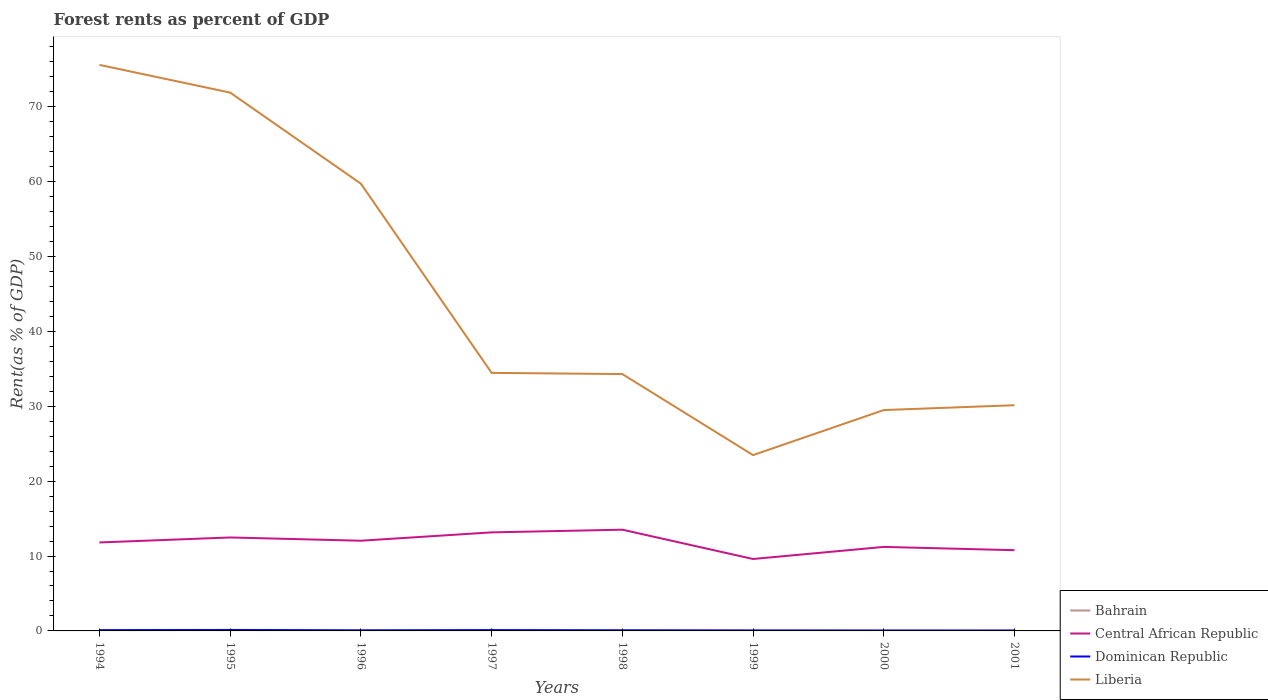Across all years, what is the maximum forest rent in Bahrain?
Provide a succinct answer. 0. In which year was the forest rent in Central African Republic maximum?
Offer a terse response. 1999. What is the total forest rent in Liberia in the graph?
Your response must be concise. 10.82. What is the difference between the highest and the second highest forest rent in Central African Republic?
Give a very brief answer. 3.91. What is the difference between the highest and the lowest forest rent in Bahrain?
Offer a terse response. 4. How many lines are there?
Provide a succinct answer. 4. How many years are there in the graph?
Provide a succinct answer. 8. Does the graph contain any zero values?
Provide a short and direct response. No. Does the graph contain grids?
Your response must be concise. No. How many legend labels are there?
Your answer should be very brief. 4. What is the title of the graph?
Your response must be concise. Forest rents as percent of GDP. What is the label or title of the X-axis?
Keep it short and to the point. Years. What is the label or title of the Y-axis?
Make the answer very short. Rent(as % of GDP). What is the Rent(as % of GDP) of Bahrain in 1994?
Make the answer very short. 0. What is the Rent(as % of GDP) of Central African Republic in 1994?
Your answer should be very brief. 11.81. What is the Rent(as % of GDP) in Dominican Republic in 1994?
Make the answer very short. 0.11. What is the Rent(as % of GDP) of Liberia in 1994?
Make the answer very short. 75.57. What is the Rent(as % of GDP) in Bahrain in 1995?
Ensure brevity in your answer.  0. What is the Rent(as % of GDP) in Central African Republic in 1995?
Your answer should be very brief. 12.48. What is the Rent(as % of GDP) in Dominican Republic in 1995?
Your response must be concise. 0.13. What is the Rent(as % of GDP) of Liberia in 1995?
Keep it short and to the point. 71.87. What is the Rent(as % of GDP) of Bahrain in 1996?
Offer a very short reply. 0. What is the Rent(as % of GDP) of Central African Republic in 1996?
Make the answer very short. 12.04. What is the Rent(as % of GDP) in Dominican Republic in 1996?
Your answer should be compact. 0.08. What is the Rent(as % of GDP) of Liberia in 1996?
Make the answer very short. 59.71. What is the Rent(as % of GDP) in Bahrain in 1997?
Your answer should be compact. 0. What is the Rent(as % of GDP) in Central African Republic in 1997?
Provide a short and direct response. 13.16. What is the Rent(as % of GDP) in Dominican Republic in 1997?
Make the answer very short. 0.11. What is the Rent(as % of GDP) in Liberia in 1997?
Make the answer very short. 34.45. What is the Rent(as % of GDP) in Bahrain in 1998?
Your answer should be very brief. 0. What is the Rent(as % of GDP) in Central African Republic in 1998?
Keep it short and to the point. 13.52. What is the Rent(as % of GDP) of Dominican Republic in 1998?
Your answer should be very brief. 0.09. What is the Rent(as % of GDP) in Liberia in 1998?
Your response must be concise. 34.29. What is the Rent(as % of GDP) of Bahrain in 1999?
Provide a short and direct response. 0. What is the Rent(as % of GDP) in Central African Republic in 1999?
Offer a very short reply. 9.6. What is the Rent(as % of GDP) in Dominican Republic in 1999?
Make the answer very short. 0.07. What is the Rent(as % of GDP) in Liberia in 1999?
Provide a succinct answer. 23.47. What is the Rent(as % of GDP) of Bahrain in 2000?
Provide a short and direct response. 0. What is the Rent(as % of GDP) of Central African Republic in 2000?
Offer a very short reply. 11.22. What is the Rent(as % of GDP) of Dominican Republic in 2000?
Make the answer very short. 0.06. What is the Rent(as % of GDP) in Liberia in 2000?
Provide a succinct answer. 29.49. What is the Rent(as % of GDP) in Bahrain in 2001?
Your response must be concise. 0. What is the Rent(as % of GDP) of Central African Republic in 2001?
Provide a succinct answer. 10.78. What is the Rent(as % of GDP) of Dominican Republic in 2001?
Make the answer very short. 0.06. What is the Rent(as % of GDP) in Liberia in 2001?
Offer a very short reply. 30.13. Across all years, what is the maximum Rent(as % of GDP) of Bahrain?
Offer a terse response. 0. Across all years, what is the maximum Rent(as % of GDP) of Central African Republic?
Provide a short and direct response. 13.52. Across all years, what is the maximum Rent(as % of GDP) of Dominican Republic?
Your answer should be very brief. 0.13. Across all years, what is the maximum Rent(as % of GDP) of Liberia?
Offer a terse response. 75.57. Across all years, what is the minimum Rent(as % of GDP) in Bahrain?
Keep it short and to the point. 0. Across all years, what is the minimum Rent(as % of GDP) of Central African Republic?
Your response must be concise. 9.6. Across all years, what is the minimum Rent(as % of GDP) of Dominican Republic?
Your answer should be compact. 0.06. Across all years, what is the minimum Rent(as % of GDP) of Liberia?
Your answer should be very brief. 23.47. What is the total Rent(as % of GDP) in Bahrain in the graph?
Your answer should be very brief. 0.01. What is the total Rent(as % of GDP) in Central African Republic in the graph?
Your response must be concise. 94.6. What is the total Rent(as % of GDP) of Dominican Republic in the graph?
Offer a terse response. 0.7. What is the total Rent(as % of GDP) in Liberia in the graph?
Give a very brief answer. 358.99. What is the difference between the Rent(as % of GDP) of Bahrain in 1994 and that in 1995?
Ensure brevity in your answer.  -0. What is the difference between the Rent(as % of GDP) in Central African Republic in 1994 and that in 1995?
Your answer should be very brief. -0.67. What is the difference between the Rent(as % of GDP) in Dominican Republic in 1994 and that in 1995?
Your answer should be compact. -0.02. What is the difference between the Rent(as % of GDP) in Liberia in 1994 and that in 1995?
Keep it short and to the point. 3.7. What is the difference between the Rent(as % of GDP) in Bahrain in 1994 and that in 1996?
Make the answer very short. -0. What is the difference between the Rent(as % of GDP) in Central African Republic in 1994 and that in 1996?
Provide a short and direct response. -0.23. What is the difference between the Rent(as % of GDP) of Dominican Republic in 1994 and that in 1996?
Ensure brevity in your answer.  0.02. What is the difference between the Rent(as % of GDP) of Liberia in 1994 and that in 1996?
Offer a very short reply. 15.86. What is the difference between the Rent(as % of GDP) in Bahrain in 1994 and that in 1997?
Offer a very short reply. -0. What is the difference between the Rent(as % of GDP) in Central African Republic in 1994 and that in 1997?
Your response must be concise. -1.35. What is the difference between the Rent(as % of GDP) of Dominican Republic in 1994 and that in 1997?
Make the answer very short. -0.01. What is the difference between the Rent(as % of GDP) in Liberia in 1994 and that in 1997?
Your answer should be very brief. 41.12. What is the difference between the Rent(as % of GDP) in Bahrain in 1994 and that in 1998?
Your answer should be compact. -0. What is the difference between the Rent(as % of GDP) in Central African Republic in 1994 and that in 1998?
Keep it short and to the point. -1.7. What is the difference between the Rent(as % of GDP) of Dominican Republic in 1994 and that in 1998?
Ensure brevity in your answer.  0.02. What is the difference between the Rent(as % of GDP) of Liberia in 1994 and that in 1998?
Ensure brevity in your answer.  41.28. What is the difference between the Rent(as % of GDP) of Bahrain in 1994 and that in 1999?
Your answer should be very brief. -0. What is the difference between the Rent(as % of GDP) in Central African Republic in 1994 and that in 1999?
Give a very brief answer. 2.21. What is the difference between the Rent(as % of GDP) in Dominican Republic in 1994 and that in 1999?
Keep it short and to the point. 0.04. What is the difference between the Rent(as % of GDP) of Liberia in 1994 and that in 1999?
Offer a terse response. 52.1. What is the difference between the Rent(as % of GDP) in Central African Republic in 1994 and that in 2000?
Provide a short and direct response. 0.59. What is the difference between the Rent(as % of GDP) of Dominican Republic in 1994 and that in 2000?
Your response must be concise. 0.04. What is the difference between the Rent(as % of GDP) of Liberia in 1994 and that in 2000?
Give a very brief answer. 46.09. What is the difference between the Rent(as % of GDP) in Central African Republic in 1994 and that in 2001?
Make the answer very short. 1.03. What is the difference between the Rent(as % of GDP) in Dominican Republic in 1994 and that in 2001?
Your answer should be very brief. 0.05. What is the difference between the Rent(as % of GDP) in Liberia in 1994 and that in 2001?
Your answer should be compact. 45.44. What is the difference between the Rent(as % of GDP) in Bahrain in 1995 and that in 1996?
Your response must be concise. -0. What is the difference between the Rent(as % of GDP) of Central African Republic in 1995 and that in 1996?
Your answer should be compact. 0.44. What is the difference between the Rent(as % of GDP) in Dominican Republic in 1995 and that in 1996?
Provide a short and direct response. 0.05. What is the difference between the Rent(as % of GDP) of Liberia in 1995 and that in 1996?
Offer a terse response. 12.16. What is the difference between the Rent(as % of GDP) of Bahrain in 1995 and that in 1997?
Offer a very short reply. -0. What is the difference between the Rent(as % of GDP) in Central African Republic in 1995 and that in 1997?
Give a very brief answer. -0.68. What is the difference between the Rent(as % of GDP) in Dominican Republic in 1995 and that in 1997?
Keep it short and to the point. 0.02. What is the difference between the Rent(as % of GDP) of Liberia in 1995 and that in 1997?
Your answer should be very brief. 37.42. What is the difference between the Rent(as % of GDP) of Bahrain in 1995 and that in 1998?
Keep it short and to the point. -0. What is the difference between the Rent(as % of GDP) in Central African Republic in 1995 and that in 1998?
Your answer should be very brief. -1.04. What is the difference between the Rent(as % of GDP) of Dominican Republic in 1995 and that in 1998?
Provide a succinct answer. 0.04. What is the difference between the Rent(as % of GDP) in Liberia in 1995 and that in 1998?
Make the answer very short. 37.58. What is the difference between the Rent(as % of GDP) in Bahrain in 1995 and that in 1999?
Provide a succinct answer. 0. What is the difference between the Rent(as % of GDP) in Central African Republic in 1995 and that in 1999?
Provide a succinct answer. 2.88. What is the difference between the Rent(as % of GDP) of Dominican Republic in 1995 and that in 1999?
Your answer should be very brief. 0.06. What is the difference between the Rent(as % of GDP) of Liberia in 1995 and that in 1999?
Offer a terse response. 48.4. What is the difference between the Rent(as % of GDP) of Bahrain in 1995 and that in 2000?
Provide a short and direct response. 0. What is the difference between the Rent(as % of GDP) of Central African Republic in 1995 and that in 2000?
Provide a short and direct response. 1.26. What is the difference between the Rent(as % of GDP) in Dominican Republic in 1995 and that in 2000?
Your answer should be compact. 0.07. What is the difference between the Rent(as % of GDP) of Liberia in 1995 and that in 2000?
Offer a terse response. 42.38. What is the difference between the Rent(as % of GDP) of Central African Republic in 1995 and that in 2001?
Ensure brevity in your answer.  1.7. What is the difference between the Rent(as % of GDP) in Dominican Republic in 1995 and that in 2001?
Ensure brevity in your answer.  0.07. What is the difference between the Rent(as % of GDP) in Liberia in 1995 and that in 2001?
Your answer should be very brief. 41.74. What is the difference between the Rent(as % of GDP) in Bahrain in 1996 and that in 1997?
Offer a terse response. -0. What is the difference between the Rent(as % of GDP) of Central African Republic in 1996 and that in 1997?
Give a very brief answer. -1.12. What is the difference between the Rent(as % of GDP) in Dominican Republic in 1996 and that in 1997?
Provide a short and direct response. -0.03. What is the difference between the Rent(as % of GDP) of Liberia in 1996 and that in 1997?
Provide a succinct answer. 25.26. What is the difference between the Rent(as % of GDP) of Bahrain in 1996 and that in 1998?
Your response must be concise. -0. What is the difference between the Rent(as % of GDP) in Central African Republic in 1996 and that in 1998?
Ensure brevity in your answer.  -1.47. What is the difference between the Rent(as % of GDP) in Dominican Republic in 1996 and that in 1998?
Provide a short and direct response. -0. What is the difference between the Rent(as % of GDP) of Liberia in 1996 and that in 1998?
Provide a succinct answer. 25.42. What is the difference between the Rent(as % of GDP) of Central African Republic in 1996 and that in 1999?
Offer a very short reply. 2.44. What is the difference between the Rent(as % of GDP) in Dominican Republic in 1996 and that in 1999?
Offer a very short reply. 0.01. What is the difference between the Rent(as % of GDP) in Liberia in 1996 and that in 1999?
Give a very brief answer. 36.24. What is the difference between the Rent(as % of GDP) in Bahrain in 1996 and that in 2000?
Your answer should be compact. 0. What is the difference between the Rent(as % of GDP) in Central African Republic in 1996 and that in 2000?
Your response must be concise. 0.83. What is the difference between the Rent(as % of GDP) of Dominican Republic in 1996 and that in 2000?
Keep it short and to the point. 0.02. What is the difference between the Rent(as % of GDP) in Liberia in 1996 and that in 2000?
Provide a succinct answer. 30.22. What is the difference between the Rent(as % of GDP) in Bahrain in 1996 and that in 2001?
Your answer should be compact. 0. What is the difference between the Rent(as % of GDP) of Central African Republic in 1996 and that in 2001?
Your answer should be compact. 1.26. What is the difference between the Rent(as % of GDP) in Dominican Republic in 1996 and that in 2001?
Offer a very short reply. 0.02. What is the difference between the Rent(as % of GDP) in Liberia in 1996 and that in 2001?
Keep it short and to the point. 29.58. What is the difference between the Rent(as % of GDP) of Bahrain in 1997 and that in 1998?
Offer a terse response. -0. What is the difference between the Rent(as % of GDP) of Central African Republic in 1997 and that in 1998?
Your answer should be compact. -0.36. What is the difference between the Rent(as % of GDP) of Dominican Republic in 1997 and that in 1998?
Your answer should be very brief. 0.02. What is the difference between the Rent(as % of GDP) of Liberia in 1997 and that in 1998?
Give a very brief answer. 0.16. What is the difference between the Rent(as % of GDP) of Bahrain in 1997 and that in 1999?
Keep it short and to the point. 0. What is the difference between the Rent(as % of GDP) in Central African Republic in 1997 and that in 1999?
Your response must be concise. 3.55. What is the difference between the Rent(as % of GDP) in Dominican Republic in 1997 and that in 1999?
Your answer should be compact. 0.04. What is the difference between the Rent(as % of GDP) of Liberia in 1997 and that in 1999?
Keep it short and to the point. 10.98. What is the difference between the Rent(as % of GDP) of Bahrain in 1997 and that in 2000?
Offer a very short reply. 0. What is the difference between the Rent(as % of GDP) in Central African Republic in 1997 and that in 2000?
Keep it short and to the point. 1.94. What is the difference between the Rent(as % of GDP) of Dominican Republic in 1997 and that in 2000?
Offer a terse response. 0.05. What is the difference between the Rent(as % of GDP) in Liberia in 1997 and that in 2000?
Your answer should be very brief. 4.96. What is the difference between the Rent(as % of GDP) of Bahrain in 1997 and that in 2001?
Your answer should be very brief. 0. What is the difference between the Rent(as % of GDP) in Central African Republic in 1997 and that in 2001?
Provide a short and direct response. 2.38. What is the difference between the Rent(as % of GDP) in Dominican Republic in 1997 and that in 2001?
Your answer should be very brief. 0.05. What is the difference between the Rent(as % of GDP) in Liberia in 1997 and that in 2001?
Your answer should be compact. 4.32. What is the difference between the Rent(as % of GDP) of Central African Republic in 1998 and that in 1999?
Keep it short and to the point. 3.91. What is the difference between the Rent(as % of GDP) in Dominican Republic in 1998 and that in 1999?
Your answer should be very brief. 0.02. What is the difference between the Rent(as % of GDP) of Liberia in 1998 and that in 1999?
Your answer should be very brief. 10.82. What is the difference between the Rent(as % of GDP) in Bahrain in 1998 and that in 2000?
Ensure brevity in your answer.  0. What is the difference between the Rent(as % of GDP) in Central African Republic in 1998 and that in 2000?
Keep it short and to the point. 2.3. What is the difference between the Rent(as % of GDP) of Dominican Republic in 1998 and that in 2000?
Give a very brief answer. 0.03. What is the difference between the Rent(as % of GDP) of Liberia in 1998 and that in 2000?
Offer a terse response. 4.81. What is the difference between the Rent(as % of GDP) of Bahrain in 1998 and that in 2001?
Ensure brevity in your answer.  0. What is the difference between the Rent(as % of GDP) in Central African Republic in 1998 and that in 2001?
Provide a short and direct response. 2.74. What is the difference between the Rent(as % of GDP) of Dominican Republic in 1998 and that in 2001?
Keep it short and to the point. 0.03. What is the difference between the Rent(as % of GDP) of Liberia in 1998 and that in 2001?
Ensure brevity in your answer.  4.16. What is the difference between the Rent(as % of GDP) of Central African Republic in 1999 and that in 2000?
Keep it short and to the point. -1.61. What is the difference between the Rent(as % of GDP) in Dominican Republic in 1999 and that in 2000?
Offer a very short reply. 0.01. What is the difference between the Rent(as % of GDP) in Liberia in 1999 and that in 2000?
Give a very brief answer. -6.01. What is the difference between the Rent(as % of GDP) of Bahrain in 1999 and that in 2001?
Ensure brevity in your answer.  0. What is the difference between the Rent(as % of GDP) of Central African Republic in 1999 and that in 2001?
Keep it short and to the point. -1.18. What is the difference between the Rent(as % of GDP) of Dominican Republic in 1999 and that in 2001?
Give a very brief answer. 0.01. What is the difference between the Rent(as % of GDP) of Liberia in 1999 and that in 2001?
Ensure brevity in your answer.  -6.66. What is the difference between the Rent(as % of GDP) of Central African Republic in 2000 and that in 2001?
Offer a terse response. 0.44. What is the difference between the Rent(as % of GDP) in Dominican Republic in 2000 and that in 2001?
Provide a succinct answer. 0. What is the difference between the Rent(as % of GDP) in Liberia in 2000 and that in 2001?
Give a very brief answer. -0.65. What is the difference between the Rent(as % of GDP) in Bahrain in 1994 and the Rent(as % of GDP) in Central African Republic in 1995?
Your response must be concise. -12.48. What is the difference between the Rent(as % of GDP) of Bahrain in 1994 and the Rent(as % of GDP) of Dominican Republic in 1995?
Your answer should be very brief. -0.13. What is the difference between the Rent(as % of GDP) of Bahrain in 1994 and the Rent(as % of GDP) of Liberia in 1995?
Offer a terse response. -71.87. What is the difference between the Rent(as % of GDP) in Central African Republic in 1994 and the Rent(as % of GDP) in Dominican Republic in 1995?
Offer a very short reply. 11.68. What is the difference between the Rent(as % of GDP) of Central African Republic in 1994 and the Rent(as % of GDP) of Liberia in 1995?
Make the answer very short. -60.06. What is the difference between the Rent(as % of GDP) in Dominican Republic in 1994 and the Rent(as % of GDP) in Liberia in 1995?
Provide a short and direct response. -71.77. What is the difference between the Rent(as % of GDP) of Bahrain in 1994 and the Rent(as % of GDP) of Central African Republic in 1996?
Provide a succinct answer. -12.04. What is the difference between the Rent(as % of GDP) in Bahrain in 1994 and the Rent(as % of GDP) in Dominican Republic in 1996?
Make the answer very short. -0.08. What is the difference between the Rent(as % of GDP) of Bahrain in 1994 and the Rent(as % of GDP) of Liberia in 1996?
Offer a very short reply. -59.71. What is the difference between the Rent(as % of GDP) of Central African Republic in 1994 and the Rent(as % of GDP) of Dominican Republic in 1996?
Give a very brief answer. 11.73. What is the difference between the Rent(as % of GDP) of Central African Republic in 1994 and the Rent(as % of GDP) of Liberia in 1996?
Your response must be concise. -47.9. What is the difference between the Rent(as % of GDP) of Dominican Republic in 1994 and the Rent(as % of GDP) of Liberia in 1996?
Your answer should be very brief. -59.6. What is the difference between the Rent(as % of GDP) of Bahrain in 1994 and the Rent(as % of GDP) of Central African Republic in 1997?
Ensure brevity in your answer.  -13.16. What is the difference between the Rent(as % of GDP) in Bahrain in 1994 and the Rent(as % of GDP) in Dominican Republic in 1997?
Ensure brevity in your answer.  -0.11. What is the difference between the Rent(as % of GDP) of Bahrain in 1994 and the Rent(as % of GDP) of Liberia in 1997?
Make the answer very short. -34.45. What is the difference between the Rent(as % of GDP) in Central African Republic in 1994 and the Rent(as % of GDP) in Dominican Republic in 1997?
Your answer should be compact. 11.7. What is the difference between the Rent(as % of GDP) of Central African Republic in 1994 and the Rent(as % of GDP) of Liberia in 1997?
Your answer should be compact. -22.64. What is the difference between the Rent(as % of GDP) of Dominican Republic in 1994 and the Rent(as % of GDP) of Liberia in 1997?
Give a very brief answer. -34.35. What is the difference between the Rent(as % of GDP) of Bahrain in 1994 and the Rent(as % of GDP) of Central African Republic in 1998?
Your answer should be compact. -13.51. What is the difference between the Rent(as % of GDP) of Bahrain in 1994 and the Rent(as % of GDP) of Dominican Republic in 1998?
Provide a short and direct response. -0.09. What is the difference between the Rent(as % of GDP) of Bahrain in 1994 and the Rent(as % of GDP) of Liberia in 1998?
Your answer should be compact. -34.29. What is the difference between the Rent(as % of GDP) of Central African Republic in 1994 and the Rent(as % of GDP) of Dominican Republic in 1998?
Give a very brief answer. 11.72. What is the difference between the Rent(as % of GDP) of Central African Republic in 1994 and the Rent(as % of GDP) of Liberia in 1998?
Ensure brevity in your answer.  -22.48. What is the difference between the Rent(as % of GDP) in Dominican Republic in 1994 and the Rent(as % of GDP) in Liberia in 1998?
Your answer should be very brief. -34.19. What is the difference between the Rent(as % of GDP) in Bahrain in 1994 and the Rent(as % of GDP) in Central African Republic in 1999?
Ensure brevity in your answer.  -9.6. What is the difference between the Rent(as % of GDP) in Bahrain in 1994 and the Rent(as % of GDP) in Dominican Republic in 1999?
Keep it short and to the point. -0.07. What is the difference between the Rent(as % of GDP) of Bahrain in 1994 and the Rent(as % of GDP) of Liberia in 1999?
Provide a short and direct response. -23.47. What is the difference between the Rent(as % of GDP) of Central African Republic in 1994 and the Rent(as % of GDP) of Dominican Republic in 1999?
Ensure brevity in your answer.  11.74. What is the difference between the Rent(as % of GDP) in Central African Republic in 1994 and the Rent(as % of GDP) in Liberia in 1999?
Your answer should be compact. -11.66. What is the difference between the Rent(as % of GDP) of Dominican Republic in 1994 and the Rent(as % of GDP) of Liberia in 1999?
Offer a very short reply. -23.37. What is the difference between the Rent(as % of GDP) of Bahrain in 1994 and the Rent(as % of GDP) of Central African Republic in 2000?
Ensure brevity in your answer.  -11.22. What is the difference between the Rent(as % of GDP) of Bahrain in 1994 and the Rent(as % of GDP) of Dominican Republic in 2000?
Make the answer very short. -0.06. What is the difference between the Rent(as % of GDP) in Bahrain in 1994 and the Rent(as % of GDP) in Liberia in 2000?
Provide a succinct answer. -29.49. What is the difference between the Rent(as % of GDP) in Central African Republic in 1994 and the Rent(as % of GDP) in Dominican Republic in 2000?
Provide a succinct answer. 11.75. What is the difference between the Rent(as % of GDP) in Central African Republic in 1994 and the Rent(as % of GDP) in Liberia in 2000?
Keep it short and to the point. -17.68. What is the difference between the Rent(as % of GDP) in Dominican Republic in 1994 and the Rent(as % of GDP) in Liberia in 2000?
Your answer should be compact. -29.38. What is the difference between the Rent(as % of GDP) in Bahrain in 1994 and the Rent(as % of GDP) in Central African Republic in 2001?
Provide a short and direct response. -10.78. What is the difference between the Rent(as % of GDP) of Bahrain in 1994 and the Rent(as % of GDP) of Dominican Republic in 2001?
Ensure brevity in your answer.  -0.06. What is the difference between the Rent(as % of GDP) in Bahrain in 1994 and the Rent(as % of GDP) in Liberia in 2001?
Your answer should be very brief. -30.13. What is the difference between the Rent(as % of GDP) in Central African Republic in 1994 and the Rent(as % of GDP) in Dominican Republic in 2001?
Keep it short and to the point. 11.75. What is the difference between the Rent(as % of GDP) of Central African Republic in 1994 and the Rent(as % of GDP) of Liberia in 2001?
Keep it short and to the point. -18.32. What is the difference between the Rent(as % of GDP) in Dominican Republic in 1994 and the Rent(as % of GDP) in Liberia in 2001?
Provide a succinct answer. -30.03. What is the difference between the Rent(as % of GDP) in Bahrain in 1995 and the Rent(as % of GDP) in Central African Republic in 1996?
Make the answer very short. -12.04. What is the difference between the Rent(as % of GDP) in Bahrain in 1995 and the Rent(as % of GDP) in Dominican Republic in 1996?
Your response must be concise. -0.08. What is the difference between the Rent(as % of GDP) in Bahrain in 1995 and the Rent(as % of GDP) in Liberia in 1996?
Keep it short and to the point. -59.71. What is the difference between the Rent(as % of GDP) in Central African Republic in 1995 and the Rent(as % of GDP) in Dominican Republic in 1996?
Offer a very short reply. 12.4. What is the difference between the Rent(as % of GDP) in Central African Republic in 1995 and the Rent(as % of GDP) in Liberia in 1996?
Provide a succinct answer. -47.23. What is the difference between the Rent(as % of GDP) of Dominican Republic in 1995 and the Rent(as % of GDP) of Liberia in 1996?
Ensure brevity in your answer.  -59.58. What is the difference between the Rent(as % of GDP) of Bahrain in 1995 and the Rent(as % of GDP) of Central African Republic in 1997?
Offer a terse response. -13.16. What is the difference between the Rent(as % of GDP) of Bahrain in 1995 and the Rent(as % of GDP) of Dominican Republic in 1997?
Offer a very short reply. -0.11. What is the difference between the Rent(as % of GDP) in Bahrain in 1995 and the Rent(as % of GDP) in Liberia in 1997?
Your response must be concise. -34.45. What is the difference between the Rent(as % of GDP) of Central African Republic in 1995 and the Rent(as % of GDP) of Dominican Republic in 1997?
Your answer should be compact. 12.37. What is the difference between the Rent(as % of GDP) in Central African Republic in 1995 and the Rent(as % of GDP) in Liberia in 1997?
Ensure brevity in your answer.  -21.97. What is the difference between the Rent(as % of GDP) in Dominican Republic in 1995 and the Rent(as % of GDP) in Liberia in 1997?
Offer a terse response. -34.32. What is the difference between the Rent(as % of GDP) of Bahrain in 1995 and the Rent(as % of GDP) of Central African Republic in 1998?
Your answer should be very brief. -13.51. What is the difference between the Rent(as % of GDP) of Bahrain in 1995 and the Rent(as % of GDP) of Dominican Republic in 1998?
Make the answer very short. -0.09. What is the difference between the Rent(as % of GDP) of Bahrain in 1995 and the Rent(as % of GDP) of Liberia in 1998?
Keep it short and to the point. -34.29. What is the difference between the Rent(as % of GDP) of Central African Republic in 1995 and the Rent(as % of GDP) of Dominican Republic in 1998?
Provide a short and direct response. 12.39. What is the difference between the Rent(as % of GDP) of Central African Republic in 1995 and the Rent(as % of GDP) of Liberia in 1998?
Your answer should be compact. -21.82. What is the difference between the Rent(as % of GDP) of Dominican Republic in 1995 and the Rent(as % of GDP) of Liberia in 1998?
Make the answer very short. -34.16. What is the difference between the Rent(as % of GDP) of Bahrain in 1995 and the Rent(as % of GDP) of Central African Republic in 1999?
Your response must be concise. -9.6. What is the difference between the Rent(as % of GDP) of Bahrain in 1995 and the Rent(as % of GDP) of Dominican Republic in 1999?
Ensure brevity in your answer.  -0.07. What is the difference between the Rent(as % of GDP) in Bahrain in 1995 and the Rent(as % of GDP) in Liberia in 1999?
Give a very brief answer. -23.47. What is the difference between the Rent(as % of GDP) in Central African Republic in 1995 and the Rent(as % of GDP) in Dominican Republic in 1999?
Keep it short and to the point. 12.41. What is the difference between the Rent(as % of GDP) of Central African Republic in 1995 and the Rent(as % of GDP) of Liberia in 1999?
Keep it short and to the point. -10.99. What is the difference between the Rent(as % of GDP) in Dominican Republic in 1995 and the Rent(as % of GDP) in Liberia in 1999?
Your answer should be very brief. -23.34. What is the difference between the Rent(as % of GDP) of Bahrain in 1995 and the Rent(as % of GDP) of Central African Republic in 2000?
Give a very brief answer. -11.22. What is the difference between the Rent(as % of GDP) of Bahrain in 1995 and the Rent(as % of GDP) of Dominican Republic in 2000?
Give a very brief answer. -0.06. What is the difference between the Rent(as % of GDP) of Bahrain in 1995 and the Rent(as % of GDP) of Liberia in 2000?
Ensure brevity in your answer.  -29.49. What is the difference between the Rent(as % of GDP) of Central African Republic in 1995 and the Rent(as % of GDP) of Dominican Republic in 2000?
Give a very brief answer. 12.42. What is the difference between the Rent(as % of GDP) in Central African Republic in 1995 and the Rent(as % of GDP) in Liberia in 2000?
Ensure brevity in your answer.  -17.01. What is the difference between the Rent(as % of GDP) of Dominican Republic in 1995 and the Rent(as % of GDP) of Liberia in 2000?
Your response must be concise. -29.36. What is the difference between the Rent(as % of GDP) in Bahrain in 1995 and the Rent(as % of GDP) in Central African Republic in 2001?
Provide a succinct answer. -10.78. What is the difference between the Rent(as % of GDP) of Bahrain in 1995 and the Rent(as % of GDP) of Dominican Republic in 2001?
Your response must be concise. -0.06. What is the difference between the Rent(as % of GDP) of Bahrain in 1995 and the Rent(as % of GDP) of Liberia in 2001?
Your response must be concise. -30.13. What is the difference between the Rent(as % of GDP) of Central African Republic in 1995 and the Rent(as % of GDP) of Dominican Republic in 2001?
Provide a succinct answer. 12.42. What is the difference between the Rent(as % of GDP) in Central African Republic in 1995 and the Rent(as % of GDP) in Liberia in 2001?
Keep it short and to the point. -17.66. What is the difference between the Rent(as % of GDP) in Dominican Republic in 1995 and the Rent(as % of GDP) in Liberia in 2001?
Provide a short and direct response. -30. What is the difference between the Rent(as % of GDP) in Bahrain in 1996 and the Rent(as % of GDP) in Central African Republic in 1997?
Offer a terse response. -13.16. What is the difference between the Rent(as % of GDP) in Bahrain in 1996 and the Rent(as % of GDP) in Dominican Republic in 1997?
Provide a short and direct response. -0.11. What is the difference between the Rent(as % of GDP) in Bahrain in 1996 and the Rent(as % of GDP) in Liberia in 1997?
Provide a short and direct response. -34.45. What is the difference between the Rent(as % of GDP) of Central African Republic in 1996 and the Rent(as % of GDP) of Dominican Republic in 1997?
Give a very brief answer. 11.93. What is the difference between the Rent(as % of GDP) in Central African Republic in 1996 and the Rent(as % of GDP) in Liberia in 1997?
Provide a short and direct response. -22.41. What is the difference between the Rent(as % of GDP) of Dominican Republic in 1996 and the Rent(as % of GDP) of Liberia in 1997?
Your answer should be compact. -34.37. What is the difference between the Rent(as % of GDP) in Bahrain in 1996 and the Rent(as % of GDP) in Central African Republic in 1998?
Ensure brevity in your answer.  -13.51. What is the difference between the Rent(as % of GDP) of Bahrain in 1996 and the Rent(as % of GDP) of Dominican Republic in 1998?
Your answer should be compact. -0.09. What is the difference between the Rent(as % of GDP) in Bahrain in 1996 and the Rent(as % of GDP) in Liberia in 1998?
Your response must be concise. -34.29. What is the difference between the Rent(as % of GDP) in Central African Republic in 1996 and the Rent(as % of GDP) in Dominican Republic in 1998?
Offer a very short reply. 11.96. What is the difference between the Rent(as % of GDP) of Central African Republic in 1996 and the Rent(as % of GDP) of Liberia in 1998?
Ensure brevity in your answer.  -22.25. What is the difference between the Rent(as % of GDP) of Dominican Republic in 1996 and the Rent(as % of GDP) of Liberia in 1998?
Give a very brief answer. -34.21. What is the difference between the Rent(as % of GDP) in Bahrain in 1996 and the Rent(as % of GDP) in Central African Republic in 1999?
Ensure brevity in your answer.  -9.6. What is the difference between the Rent(as % of GDP) of Bahrain in 1996 and the Rent(as % of GDP) of Dominican Republic in 1999?
Provide a short and direct response. -0.07. What is the difference between the Rent(as % of GDP) of Bahrain in 1996 and the Rent(as % of GDP) of Liberia in 1999?
Your answer should be very brief. -23.47. What is the difference between the Rent(as % of GDP) in Central African Republic in 1996 and the Rent(as % of GDP) in Dominican Republic in 1999?
Provide a succinct answer. 11.97. What is the difference between the Rent(as % of GDP) in Central African Republic in 1996 and the Rent(as % of GDP) in Liberia in 1999?
Your answer should be compact. -11.43. What is the difference between the Rent(as % of GDP) in Dominican Republic in 1996 and the Rent(as % of GDP) in Liberia in 1999?
Ensure brevity in your answer.  -23.39. What is the difference between the Rent(as % of GDP) in Bahrain in 1996 and the Rent(as % of GDP) in Central African Republic in 2000?
Make the answer very short. -11.22. What is the difference between the Rent(as % of GDP) of Bahrain in 1996 and the Rent(as % of GDP) of Dominican Republic in 2000?
Provide a succinct answer. -0.06. What is the difference between the Rent(as % of GDP) of Bahrain in 1996 and the Rent(as % of GDP) of Liberia in 2000?
Keep it short and to the point. -29.49. What is the difference between the Rent(as % of GDP) of Central African Republic in 1996 and the Rent(as % of GDP) of Dominican Republic in 2000?
Offer a very short reply. 11.98. What is the difference between the Rent(as % of GDP) of Central African Republic in 1996 and the Rent(as % of GDP) of Liberia in 2000?
Provide a succinct answer. -17.44. What is the difference between the Rent(as % of GDP) of Dominican Republic in 1996 and the Rent(as % of GDP) of Liberia in 2000?
Offer a very short reply. -29.4. What is the difference between the Rent(as % of GDP) of Bahrain in 1996 and the Rent(as % of GDP) of Central African Republic in 2001?
Your response must be concise. -10.78. What is the difference between the Rent(as % of GDP) of Bahrain in 1996 and the Rent(as % of GDP) of Dominican Republic in 2001?
Offer a terse response. -0.06. What is the difference between the Rent(as % of GDP) in Bahrain in 1996 and the Rent(as % of GDP) in Liberia in 2001?
Offer a very short reply. -30.13. What is the difference between the Rent(as % of GDP) of Central African Republic in 1996 and the Rent(as % of GDP) of Dominican Republic in 2001?
Offer a terse response. 11.98. What is the difference between the Rent(as % of GDP) in Central African Republic in 1996 and the Rent(as % of GDP) in Liberia in 2001?
Make the answer very short. -18.09. What is the difference between the Rent(as % of GDP) in Dominican Republic in 1996 and the Rent(as % of GDP) in Liberia in 2001?
Ensure brevity in your answer.  -30.05. What is the difference between the Rent(as % of GDP) in Bahrain in 1997 and the Rent(as % of GDP) in Central African Republic in 1998?
Provide a succinct answer. -13.51. What is the difference between the Rent(as % of GDP) of Bahrain in 1997 and the Rent(as % of GDP) of Dominican Republic in 1998?
Offer a terse response. -0.09. What is the difference between the Rent(as % of GDP) in Bahrain in 1997 and the Rent(as % of GDP) in Liberia in 1998?
Offer a very short reply. -34.29. What is the difference between the Rent(as % of GDP) in Central African Republic in 1997 and the Rent(as % of GDP) in Dominican Republic in 1998?
Your answer should be very brief. 13.07. What is the difference between the Rent(as % of GDP) of Central African Republic in 1997 and the Rent(as % of GDP) of Liberia in 1998?
Keep it short and to the point. -21.14. What is the difference between the Rent(as % of GDP) in Dominican Republic in 1997 and the Rent(as % of GDP) in Liberia in 1998?
Provide a short and direct response. -34.18. What is the difference between the Rent(as % of GDP) in Bahrain in 1997 and the Rent(as % of GDP) in Central African Republic in 1999?
Your answer should be compact. -9.6. What is the difference between the Rent(as % of GDP) of Bahrain in 1997 and the Rent(as % of GDP) of Dominican Republic in 1999?
Your answer should be very brief. -0.07. What is the difference between the Rent(as % of GDP) in Bahrain in 1997 and the Rent(as % of GDP) in Liberia in 1999?
Keep it short and to the point. -23.47. What is the difference between the Rent(as % of GDP) of Central African Republic in 1997 and the Rent(as % of GDP) of Dominican Republic in 1999?
Give a very brief answer. 13.09. What is the difference between the Rent(as % of GDP) in Central African Republic in 1997 and the Rent(as % of GDP) in Liberia in 1999?
Your answer should be compact. -10.31. What is the difference between the Rent(as % of GDP) of Dominican Republic in 1997 and the Rent(as % of GDP) of Liberia in 1999?
Give a very brief answer. -23.36. What is the difference between the Rent(as % of GDP) of Bahrain in 1997 and the Rent(as % of GDP) of Central African Republic in 2000?
Offer a very short reply. -11.21. What is the difference between the Rent(as % of GDP) in Bahrain in 1997 and the Rent(as % of GDP) in Dominican Republic in 2000?
Offer a very short reply. -0.06. What is the difference between the Rent(as % of GDP) of Bahrain in 1997 and the Rent(as % of GDP) of Liberia in 2000?
Make the answer very short. -29.49. What is the difference between the Rent(as % of GDP) of Central African Republic in 1997 and the Rent(as % of GDP) of Dominican Republic in 2000?
Give a very brief answer. 13.1. What is the difference between the Rent(as % of GDP) in Central African Republic in 1997 and the Rent(as % of GDP) in Liberia in 2000?
Your response must be concise. -16.33. What is the difference between the Rent(as % of GDP) in Dominican Republic in 1997 and the Rent(as % of GDP) in Liberia in 2000?
Keep it short and to the point. -29.38. What is the difference between the Rent(as % of GDP) of Bahrain in 1997 and the Rent(as % of GDP) of Central African Republic in 2001?
Provide a succinct answer. -10.78. What is the difference between the Rent(as % of GDP) in Bahrain in 1997 and the Rent(as % of GDP) in Dominican Republic in 2001?
Your answer should be very brief. -0.06. What is the difference between the Rent(as % of GDP) of Bahrain in 1997 and the Rent(as % of GDP) of Liberia in 2001?
Provide a short and direct response. -30.13. What is the difference between the Rent(as % of GDP) in Central African Republic in 1997 and the Rent(as % of GDP) in Dominican Republic in 2001?
Provide a short and direct response. 13.1. What is the difference between the Rent(as % of GDP) in Central African Republic in 1997 and the Rent(as % of GDP) in Liberia in 2001?
Your response must be concise. -16.98. What is the difference between the Rent(as % of GDP) in Dominican Republic in 1997 and the Rent(as % of GDP) in Liberia in 2001?
Your answer should be compact. -30.02. What is the difference between the Rent(as % of GDP) of Bahrain in 1998 and the Rent(as % of GDP) of Central African Republic in 1999?
Offer a terse response. -9.6. What is the difference between the Rent(as % of GDP) in Bahrain in 1998 and the Rent(as % of GDP) in Dominican Republic in 1999?
Your answer should be very brief. -0.07. What is the difference between the Rent(as % of GDP) of Bahrain in 1998 and the Rent(as % of GDP) of Liberia in 1999?
Offer a terse response. -23.47. What is the difference between the Rent(as % of GDP) of Central African Republic in 1998 and the Rent(as % of GDP) of Dominican Republic in 1999?
Your response must be concise. 13.45. What is the difference between the Rent(as % of GDP) in Central African Republic in 1998 and the Rent(as % of GDP) in Liberia in 1999?
Your answer should be very brief. -9.96. What is the difference between the Rent(as % of GDP) in Dominican Republic in 1998 and the Rent(as % of GDP) in Liberia in 1999?
Give a very brief answer. -23.39. What is the difference between the Rent(as % of GDP) in Bahrain in 1998 and the Rent(as % of GDP) in Central African Republic in 2000?
Provide a short and direct response. -11.21. What is the difference between the Rent(as % of GDP) of Bahrain in 1998 and the Rent(as % of GDP) of Dominican Republic in 2000?
Offer a very short reply. -0.06. What is the difference between the Rent(as % of GDP) of Bahrain in 1998 and the Rent(as % of GDP) of Liberia in 2000?
Make the answer very short. -29.48. What is the difference between the Rent(as % of GDP) of Central African Republic in 1998 and the Rent(as % of GDP) of Dominican Republic in 2000?
Your answer should be compact. 13.45. What is the difference between the Rent(as % of GDP) in Central African Republic in 1998 and the Rent(as % of GDP) in Liberia in 2000?
Give a very brief answer. -15.97. What is the difference between the Rent(as % of GDP) of Dominican Republic in 1998 and the Rent(as % of GDP) of Liberia in 2000?
Offer a terse response. -29.4. What is the difference between the Rent(as % of GDP) of Bahrain in 1998 and the Rent(as % of GDP) of Central African Republic in 2001?
Your response must be concise. -10.78. What is the difference between the Rent(as % of GDP) of Bahrain in 1998 and the Rent(as % of GDP) of Dominican Republic in 2001?
Make the answer very short. -0.06. What is the difference between the Rent(as % of GDP) of Bahrain in 1998 and the Rent(as % of GDP) of Liberia in 2001?
Make the answer very short. -30.13. What is the difference between the Rent(as % of GDP) of Central African Republic in 1998 and the Rent(as % of GDP) of Dominican Republic in 2001?
Ensure brevity in your answer.  13.46. What is the difference between the Rent(as % of GDP) in Central African Republic in 1998 and the Rent(as % of GDP) in Liberia in 2001?
Offer a very short reply. -16.62. What is the difference between the Rent(as % of GDP) in Dominican Republic in 1998 and the Rent(as % of GDP) in Liberia in 2001?
Provide a short and direct response. -30.05. What is the difference between the Rent(as % of GDP) of Bahrain in 1999 and the Rent(as % of GDP) of Central African Republic in 2000?
Your response must be concise. -11.22. What is the difference between the Rent(as % of GDP) in Bahrain in 1999 and the Rent(as % of GDP) in Dominican Republic in 2000?
Offer a very short reply. -0.06. What is the difference between the Rent(as % of GDP) of Bahrain in 1999 and the Rent(as % of GDP) of Liberia in 2000?
Offer a very short reply. -29.49. What is the difference between the Rent(as % of GDP) in Central African Republic in 1999 and the Rent(as % of GDP) in Dominican Republic in 2000?
Keep it short and to the point. 9.54. What is the difference between the Rent(as % of GDP) in Central African Republic in 1999 and the Rent(as % of GDP) in Liberia in 2000?
Provide a succinct answer. -19.88. What is the difference between the Rent(as % of GDP) in Dominican Republic in 1999 and the Rent(as % of GDP) in Liberia in 2000?
Offer a terse response. -29.42. What is the difference between the Rent(as % of GDP) in Bahrain in 1999 and the Rent(as % of GDP) in Central African Republic in 2001?
Ensure brevity in your answer.  -10.78. What is the difference between the Rent(as % of GDP) of Bahrain in 1999 and the Rent(as % of GDP) of Dominican Republic in 2001?
Your response must be concise. -0.06. What is the difference between the Rent(as % of GDP) in Bahrain in 1999 and the Rent(as % of GDP) in Liberia in 2001?
Your answer should be compact. -30.13. What is the difference between the Rent(as % of GDP) of Central African Republic in 1999 and the Rent(as % of GDP) of Dominican Republic in 2001?
Provide a succinct answer. 9.54. What is the difference between the Rent(as % of GDP) in Central African Republic in 1999 and the Rent(as % of GDP) in Liberia in 2001?
Your answer should be very brief. -20.53. What is the difference between the Rent(as % of GDP) of Dominican Republic in 1999 and the Rent(as % of GDP) of Liberia in 2001?
Ensure brevity in your answer.  -30.06. What is the difference between the Rent(as % of GDP) in Bahrain in 2000 and the Rent(as % of GDP) in Central African Republic in 2001?
Ensure brevity in your answer.  -10.78. What is the difference between the Rent(as % of GDP) of Bahrain in 2000 and the Rent(as % of GDP) of Dominican Republic in 2001?
Ensure brevity in your answer.  -0.06. What is the difference between the Rent(as % of GDP) of Bahrain in 2000 and the Rent(as % of GDP) of Liberia in 2001?
Your answer should be very brief. -30.13. What is the difference between the Rent(as % of GDP) of Central African Republic in 2000 and the Rent(as % of GDP) of Dominican Republic in 2001?
Ensure brevity in your answer.  11.16. What is the difference between the Rent(as % of GDP) of Central African Republic in 2000 and the Rent(as % of GDP) of Liberia in 2001?
Give a very brief answer. -18.92. What is the difference between the Rent(as % of GDP) of Dominican Republic in 2000 and the Rent(as % of GDP) of Liberia in 2001?
Your answer should be very brief. -30.07. What is the average Rent(as % of GDP) of Bahrain per year?
Provide a short and direct response. 0. What is the average Rent(as % of GDP) in Central African Republic per year?
Offer a terse response. 11.83. What is the average Rent(as % of GDP) in Dominican Republic per year?
Ensure brevity in your answer.  0.09. What is the average Rent(as % of GDP) in Liberia per year?
Your response must be concise. 44.87. In the year 1994, what is the difference between the Rent(as % of GDP) of Bahrain and Rent(as % of GDP) of Central African Republic?
Your response must be concise. -11.81. In the year 1994, what is the difference between the Rent(as % of GDP) in Bahrain and Rent(as % of GDP) in Dominican Republic?
Your answer should be compact. -0.1. In the year 1994, what is the difference between the Rent(as % of GDP) in Bahrain and Rent(as % of GDP) in Liberia?
Make the answer very short. -75.57. In the year 1994, what is the difference between the Rent(as % of GDP) in Central African Republic and Rent(as % of GDP) in Dominican Republic?
Ensure brevity in your answer.  11.71. In the year 1994, what is the difference between the Rent(as % of GDP) in Central African Republic and Rent(as % of GDP) in Liberia?
Provide a succinct answer. -63.76. In the year 1994, what is the difference between the Rent(as % of GDP) of Dominican Republic and Rent(as % of GDP) of Liberia?
Ensure brevity in your answer.  -75.47. In the year 1995, what is the difference between the Rent(as % of GDP) in Bahrain and Rent(as % of GDP) in Central African Republic?
Your answer should be very brief. -12.48. In the year 1995, what is the difference between the Rent(as % of GDP) of Bahrain and Rent(as % of GDP) of Dominican Republic?
Ensure brevity in your answer.  -0.13. In the year 1995, what is the difference between the Rent(as % of GDP) of Bahrain and Rent(as % of GDP) of Liberia?
Your answer should be compact. -71.87. In the year 1995, what is the difference between the Rent(as % of GDP) in Central African Republic and Rent(as % of GDP) in Dominican Republic?
Offer a terse response. 12.35. In the year 1995, what is the difference between the Rent(as % of GDP) in Central African Republic and Rent(as % of GDP) in Liberia?
Provide a succinct answer. -59.39. In the year 1995, what is the difference between the Rent(as % of GDP) in Dominican Republic and Rent(as % of GDP) in Liberia?
Your answer should be very brief. -71.74. In the year 1996, what is the difference between the Rent(as % of GDP) in Bahrain and Rent(as % of GDP) in Central African Republic?
Offer a very short reply. -12.04. In the year 1996, what is the difference between the Rent(as % of GDP) in Bahrain and Rent(as % of GDP) in Dominican Republic?
Keep it short and to the point. -0.08. In the year 1996, what is the difference between the Rent(as % of GDP) in Bahrain and Rent(as % of GDP) in Liberia?
Offer a terse response. -59.71. In the year 1996, what is the difference between the Rent(as % of GDP) of Central African Republic and Rent(as % of GDP) of Dominican Republic?
Keep it short and to the point. 11.96. In the year 1996, what is the difference between the Rent(as % of GDP) of Central African Republic and Rent(as % of GDP) of Liberia?
Your answer should be compact. -47.67. In the year 1996, what is the difference between the Rent(as % of GDP) in Dominican Republic and Rent(as % of GDP) in Liberia?
Your answer should be compact. -59.63. In the year 1997, what is the difference between the Rent(as % of GDP) in Bahrain and Rent(as % of GDP) in Central African Republic?
Offer a terse response. -13.16. In the year 1997, what is the difference between the Rent(as % of GDP) of Bahrain and Rent(as % of GDP) of Dominican Republic?
Offer a terse response. -0.11. In the year 1997, what is the difference between the Rent(as % of GDP) of Bahrain and Rent(as % of GDP) of Liberia?
Offer a very short reply. -34.45. In the year 1997, what is the difference between the Rent(as % of GDP) in Central African Republic and Rent(as % of GDP) in Dominican Republic?
Ensure brevity in your answer.  13.05. In the year 1997, what is the difference between the Rent(as % of GDP) in Central African Republic and Rent(as % of GDP) in Liberia?
Ensure brevity in your answer.  -21.29. In the year 1997, what is the difference between the Rent(as % of GDP) in Dominican Republic and Rent(as % of GDP) in Liberia?
Keep it short and to the point. -34.34. In the year 1998, what is the difference between the Rent(as % of GDP) in Bahrain and Rent(as % of GDP) in Central African Republic?
Your response must be concise. -13.51. In the year 1998, what is the difference between the Rent(as % of GDP) of Bahrain and Rent(as % of GDP) of Dominican Republic?
Keep it short and to the point. -0.08. In the year 1998, what is the difference between the Rent(as % of GDP) in Bahrain and Rent(as % of GDP) in Liberia?
Provide a short and direct response. -34.29. In the year 1998, what is the difference between the Rent(as % of GDP) in Central African Republic and Rent(as % of GDP) in Dominican Republic?
Your response must be concise. 13.43. In the year 1998, what is the difference between the Rent(as % of GDP) of Central African Republic and Rent(as % of GDP) of Liberia?
Keep it short and to the point. -20.78. In the year 1998, what is the difference between the Rent(as % of GDP) of Dominican Republic and Rent(as % of GDP) of Liberia?
Provide a succinct answer. -34.21. In the year 1999, what is the difference between the Rent(as % of GDP) in Bahrain and Rent(as % of GDP) in Central African Republic?
Offer a terse response. -9.6. In the year 1999, what is the difference between the Rent(as % of GDP) of Bahrain and Rent(as % of GDP) of Dominican Republic?
Ensure brevity in your answer.  -0.07. In the year 1999, what is the difference between the Rent(as % of GDP) of Bahrain and Rent(as % of GDP) of Liberia?
Your answer should be very brief. -23.47. In the year 1999, what is the difference between the Rent(as % of GDP) in Central African Republic and Rent(as % of GDP) in Dominican Republic?
Provide a succinct answer. 9.53. In the year 1999, what is the difference between the Rent(as % of GDP) in Central African Republic and Rent(as % of GDP) in Liberia?
Offer a terse response. -13.87. In the year 1999, what is the difference between the Rent(as % of GDP) in Dominican Republic and Rent(as % of GDP) in Liberia?
Provide a short and direct response. -23.4. In the year 2000, what is the difference between the Rent(as % of GDP) of Bahrain and Rent(as % of GDP) of Central African Republic?
Offer a terse response. -11.22. In the year 2000, what is the difference between the Rent(as % of GDP) of Bahrain and Rent(as % of GDP) of Dominican Republic?
Make the answer very short. -0.06. In the year 2000, what is the difference between the Rent(as % of GDP) of Bahrain and Rent(as % of GDP) of Liberia?
Give a very brief answer. -29.49. In the year 2000, what is the difference between the Rent(as % of GDP) in Central African Republic and Rent(as % of GDP) in Dominican Republic?
Offer a terse response. 11.16. In the year 2000, what is the difference between the Rent(as % of GDP) in Central African Republic and Rent(as % of GDP) in Liberia?
Your answer should be very brief. -18.27. In the year 2000, what is the difference between the Rent(as % of GDP) of Dominican Republic and Rent(as % of GDP) of Liberia?
Your answer should be very brief. -29.43. In the year 2001, what is the difference between the Rent(as % of GDP) of Bahrain and Rent(as % of GDP) of Central African Republic?
Provide a succinct answer. -10.78. In the year 2001, what is the difference between the Rent(as % of GDP) in Bahrain and Rent(as % of GDP) in Dominican Republic?
Offer a very short reply. -0.06. In the year 2001, what is the difference between the Rent(as % of GDP) in Bahrain and Rent(as % of GDP) in Liberia?
Keep it short and to the point. -30.13. In the year 2001, what is the difference between the Rent(as % of GDP) in Central African Republic and Rent(as % of GDP) in Dominican Republic?
Provide a short and direct response. 10.72. In the year 2001, what is the difference between the Rent(as % of GDP) of Central African Republic and Rent(as % of GDP) of Liberia?
Your response must be concise. -19.35. In the year 2001, what is the difference between the Rent(as % of GDP) in Dominican Republic and Rent(as % of GDP) in Liberia?
Offer a terse response. -30.07. What is the ratio of the Rent(as % of GDP) in Bahrain in 1994 to that in 1995?
Offer a terse response. 0.84. What is the ratio of the Rent(as % of GDP) in Central African Republic in 1994 to that in 1995?
Give a very brief answer. 0.95. What is the ratio of the Rent(as % of GDP) of Dominican Republic in 1994 to that in 1995?
Provide a succinct answer. 0.82. What is the ratio of the Rent(as % of GDP) of Liberia in 1994 to that in 1995?
Give a very brief answer. 1.05. What is the ratio of the Rent(as % of GDP) in Bahrain in 1994 to that in 1996?
Your answer should be compact. 0.74. What is the ratio of the Rent(as % of GDP) in Central African Republic in 1994 to that in 1996?
Keep it short and to the point. 0.98. What is the ratio of the Rent(as % of GDP) in Dominican Republic in 1994 to that in 1996?
Offer a very short reply. 1.28. What is the ratio of the Rent(as % of GDP) of Liberia in 1994 to that in 1996?
Your answer should be compact. 1.27. What is the ratio of the Rent(as % of GDP) of Bahrain in 1994 to that in 1997?
Ensure brevity in your answer.  0.66. What is the ratio of the Rent(as % of GDP) of Central African Republic in 1994 to that in 1997?
Your answer should be compact. 0.9. What is the ratio of the Rent(as % of GDP) in Dominican Republic in 1994 to that in 1997?
Give a very brief answer. 0.95. What is the ratio of the Rent(as % of GDP) in Liberia in 1994 to that in 1997?
Give a very brief answer. 2.19. What is the ratio of the Rent(as % of GDP) of Bahrain in 1994 to that in 1998?
Your answer should be compact. 0.62. What is the ratio of the Rent(as % of GDP) of Central African Republic in 1994 to that in 1998?
Provide a short and direct response. 0.87. What is the ratio of the Rent(as % of GDP) of Dominican Republic in 1994 to that in 1998?
Provide a succinct answer. 1.21. What is the ratio of the Rent(as % of GDP) in Liberia in 1994 to that in 1998?
Give a very brief answer. 2.2. What is the ratio of the Rent(as % of GDP) of Bahrain in 1994 to that in 1999?
Offer a very short reply. 0.86. What is the ratio of the Rent(as % of GDP) of Central African Republic in 1994 to that in 1999?
Your response must be concise. 1.23. What is the ratio of the Rent(as % of GDP) of Dominican Republic in 1994 to that in 1999?
Provide a short and direct response. 1.52. What is the ratio of the Rent(as % of GDP) in Liberia in 1994 to that in 1999?
Offer a very short reply. 3.22. What is the ratio of the Rent(as % of GDP) in Bahrain in 1994 to that in 2000?
Provide a short and direct response. 1.18. What is the ratio of the Rent(as % of GDP) in Central African Republic in 1994 to that in 2000?
Your answer should be compact. 1.05. What is the ratio of the Rent(as % of GDP) in Dominican Republic in 1994 to that in 2000?
Your answer should be compact. 1.71. What is the ratio of the Rent(as % of GDP) of Liberia in 1994 to that in 2000?
Give a very brief answer. 2.56. What is the ratio of the Rent(as % of GDP) in Bahrain in 1994 to that in 2001?
Make the answer very short. 1.2. What is the ratio of the Rent(as % of GDP) of Central African Republic in 1994 to that in 2001?
Your answer should be very brief. 1.1. What is the ratio of the Rent(as % of GDP) of Dominican Republic in 1994 to that in 2001?
Provide a succinct answer. 1.77. What is the ratio of the Rent(as % of GDP) in Liberia in 1994 to that in 2001?
Offer a terse response. 2.51. What is the ratio of the Rent(as % of GDP) in Bahrain in 1995 to that in 1996?
Offer a very short reply. 0.89. What is the ratio of the Rent(as % of GDP) in Central African Republic in 1995 to that in 1996?
Provide a short and direct response. 1.04. What is the ratio of the Rent(as % of GDP) of Dominican Republic in 1995 to that in 1996?
Offer a terse response. 1.57. What is the ratio of the Rent(as % of GDP) of Liberia in 1995 to that in 1996?
Offer a terse response. 1.2. What is the ratio of the Rent(as % of GDP) in Bahrain in 1995 to that in 1997?
Your answer should be very brief. 0.79. What is the ratio of the Rent(as % of GDP) of Central African Republic in 1995 to that in 1997?
Offer a terse response. 0.95. What is the ratio of the Rent(as % of GDP) of Dominican Republic in 1995 to that in 1997?
Your answer should be very brief. 1.16. What is the ratio of the Rent(as % of GDP) in Liberia in 1995 to that in 1997?
Ensure brevity in your answer.  2.09. What is the ratio of the Rent(as % of GDP) of Bahrain in 1995 to that in 1998?
Offer a very short reply. 0.74. What is the ratio of the Rent(as % of GDP) of Central African Republic in 1995 to that in 1998?
Make the answer very short. 0.92. What is the ratio of the Rent(as % of GDP) of Dominican Republic in 1995 to that in 1998?
Your response must be concise. 1.48. What is the ratio of the Rent(as % of GDP) in Liberia in 1995 to that in 1998?
Your answer should be compact. 2.1. What is the ratio of the Rent(as % of GDP) of Bahrain in 1995 to that in 1999?
Make the answer very short. 1.03. What is the ratio of the Rent(as % of GDP) in Central African Republic in 1995 to that in 1999?
Your answer should be compact. 1.3. What is the ratio of the Rent(as % of GDP) in Dominican Republic in 1995 to that in 1999?
Provide a succinct answer. 1.87. What is the ratio of the Rent(as % of GDP) in Liberia in 1995 to that in 1999?
Provide a short and direct response. 3.06. What is the ratio of the Rent(as % of GDP) of Bahrain in 1995 to that in 2000?
Your answer should be very brief. 1.42. What is the ratio of the Rent(as % of GDP) in Central African Republic in 1995 to that in 2000?
Make the answer very short. 1.11. What is the ratio of the Rent(as % of GDP) of Dominican Republic in 1995 to that in 2000?
Your answer should be very brief. 2.1. What is the ratio of the Rent(as % of GDP) of Liberia in 1995 to that in 2000?
Provide a short and direct response. 2.44. What is the ratio of the Rent(as % of GDP) in Bahrain in 1995 to that in 2001?
Your answer should be very brief. 1.43. What is the ratio of the Rent(as % of GDP) in Central African Republic in 1995 to that in 2001?
Provide a short and direct response. 1.16. What is the ratio of the Rent(as % of GDP) of Dominican Republic in 1995 to that in 2001?
Your answer should be very brief. 2.17. What is the ratio of the Rent(as % of GDP) in Liberia in 1995 to that in 2001?
Offer a terse response. 2.39. What is the ratio of the Rent(as % of GDP) in Bahrain in 1996 to that in 1997?
Offer a very short reply. 0.89. What is the ratio of the Rent(as % of GDP) of Central African Republic in 1996 to that in 1997?
Give a very brief answer. 0.92. What is the ratio of the Rent(as % of GDP) of Dominican Republic in 1996 to that in 1997?
Your answer should be compact. 0.74. What is the ratio of the Rent(as % of GDP) in Liberia in 1996 to that in 1997?
Make the answer very short. 1.73. What is the ratio of the Rent(as % of GDP) of Bahrain in 1996 to that in 1998?
Make the answer very short. 0.84. What is the ratio of the Rent(as % of GDP) of Central African Republic in 1996 to that in 1998?
Ensure brevity in your answer.  0.89. What is the ratio of the Rent(as % of GDP) of Dominican Republic in 1996 to that in 1998?
Provide a short and direct response. 0.94. What is the ratio of the Rent(as % of GDP) in Liberia in 1996 to that in 1998?
Make the answer very short. 1.74. What is the ratio of the Rent(as % of GDP) of Bahrain in 1996 to that in 1999?
Your answer should be very brief. 1.16. What is the ratio of the Rent(as % of GDP) in Central African Republic in 1996 to that in 1999?
Offer a very short reply. 1.25. What is the ratio of the Rent(as % of GDP) of Dominican Republic in 1996 to that in 1999?
Make the answer very short. 1.19. What is the ratio of the Rent(as % of GDP) of Liberia in 1996 to that in 1999?
Your response must be concise. 2.54. What is the ratio of the Rent(as % of GDP) in Bahrain in 1996 to that in 2000?
Provide a succinct answer. 1.6. What is the ratio of the Rent(as % of GDP) of Central African Republic in 1996 to that in 2000?
Offer a terse response. 1.07. What is the ratio of the Rent(as % of GDP) of Dominican Republic in 1996 to that in 2000?
Your answer should be very brief. 1.33. What is the ratio of the Rent(as % of GDP) in Liberia in 1996 to that in 2000?
Make the answer very short. 2.02. What is the ratio of the Rent(as % of GDP) of Bahrain in 1996 to that in 2001?
Offer a terse response. 1.61. What is the ratio of the Rent(as % of GDP) in Central African Republic in 1996 to that in 2001?
Offer a terse response. 1.12. What is the ratio of the Rent(as % of GDP) of Dominican Republic in 1996 to that in 2001?
Your answer should be very brief. 1.38. What is the ratio of the Rent(as % of GDP) of Liberia in 1996 to that in 2001?
Ensure brevity in your answer.  1.98. What is the ratio of the Rent(as % of GDP) of Bahrain in 1997 to that in 1998?
Ensure brevity in your answer.  0.94. What is the ratio of the Rent(as % of GDP) in Central African Republic in 1997 to that in 1998?
Provide a succinct answer. 0.97. What is the ratio of the Rent(as % of GDP) in Dominican Republic in 1997 to that in 1998?
Provide a succinct answer. 1.27. What is the ratio of the Rent(as % of GDP) of Bahrain in 1997 to that in 1999?
Provide a succinct answer. 1.31. What is the ratio of the Rent(as % of GDP) of Central African Republic in 1997 to that in 1999?
Make the answer very short. 1.37. What is the ratio of the Rent(as % of GDP) in Dominican Republic in 1997 to that in 1999?
Offer a terse response. 1.61. What is the ratio of the Rent(as % of GDP) of Liberia in 1997 to that in 1999?
Keep it short and to the point. 1.47. What is the ratio of the Rent(as % of GDP) of Bahrain in 1997 to that in 2000?
Provide a succinct answer. 1.8. What is the ratio of the Rent(as % of GDP) in Central African Republic in 1997 to that in 2000?
Offer a very short reply. 1.17. What is the ratio of the Rent(as % of GDP) in Dominican Republic in 1997 to that in 2000?
Make the answer very short. 1.8. What is the ratio of the Rent(as % of GDP) in Liberia in 1997 to that in 2000?
Ensure brevity in your answer.  1.17. What is the ratio of the Rent(as % of GDP) of Bahrain in 1997 to that in 2001?
Provide a short and direct response. 1.81. What is the ratio of the Rent(as % of GDP) in Central African Republic in 1997 to that in 2001?
Offer a terse response. 1.22. What is the ratio of the Rent(as % of GDP) of Dominican Republic in 1997 to that in 2001?
Ensure brevity in your answer.  1.86. What is the ratio of the Rent(as % of GDP) of Liberia in 1997 to that in 2001?
Provide a short and direct response. 1.14. What is the ratio of the Rent(as % of GDP) of Bahrain in 1998 to that in 1999?
Keep it short and to the point. 1.39. What is the ratio of the Rent(as % of GDP) in Central African Republic in 1998 to that in 1999?
Your answer should be very brief. 1.41. What is the ratio of the Rent(as % of GDP) of Dominican Republic in 1998 to that in 1999?
Ensure brevity in your answer.  1.26. What is the ratio of the Rent(as % of GDP) in Liberia in 1998 to that in 1999?
Provide a succinct answer. 1.46. What is the ratio of the Rent(as % of GDP) of Bahrain in 1998 to that in 2000?
Give a very brief answer. 1.91. What is the ratio of the Rent(as % of GDP) of Central African Republic in 1998 to that in 2000?
Ensure brevity in your answer.  1.21. What is the ratio of the Rent(as % of GDP) of Dominican Republic in 1998 to that in 2000?
Make the answer very short. 1.41. What is the ratio of the Rent(as % of GDP) of Liberia in 1998 to that in 2000?
Ensure brevity in your answer.  1.16. What is the ratio of the Rent(as % of GDP) of Bahrain in 1998 to that in 2001?
Ensure brevity in your answer.  1.93. What is the ratio of the Rent(as % of GDP) of Central African Republic in 1998 to that in 2001?
Ensure brevity in your answer.  1.25. What is the ratio of the Rent(as % of GDP) of Dominican Republic in 1998 to that in 2001?
Your response must be concise. 1.46. What is the ratio of the Rent(as % of GDP) in Liberia in 1998 to that in 2001?
Provide a short and direct response. 1.14. What is the ratio of the Rent(as % of GDP) in Bahrain in 1999 to that in 2000?
Ensure brevity in your answer.  1.37. What is the ratio of the Rent(as % of GDP) in Central African Republic in 1999 to that in 2000?
Make the answer very short. 0.86. What is the ratio of the Rent(as % of GDP) in Dominican Republic in 1999 to that in 2000?
Give a very brief answer. 1.12. What is the ratio of the Rent(as % of GDP) of Liberia in 1999 to that in 2000?
Make the answer very short. 0.8. What is the ratio of the Rent(as % of GDP) in Bahrain in 1999 to that in 2001?
Your response must be concise. 1.39. What is the ratio of the Rent(as % of GDP) in Central African Republic in 1999 to that in 2001?
Provide a succinct answer. 0.89. What is the ratio of the Rent(as % of GDP) in Dominican Republic in 1999 to that in 2001?
Offer a terse response. 1.16. What is the ratio of the Rent(as % of GDP) in Liberia in 1999 to that in 2001?
Your answer should be compact. 0.78. What is the ratio of the Rent(as % of GDP) in Bahrain in 2000 to that in 2001?
Ensure brevity in your answer.  1.01. What is the ratio of the Rent(as % of GDP) in Central African Republic in 2000 to that in 2001?
Ensure brevity in your answer.  1.04. What is the ratio of the Rent(as % of GDP) of Dominican Republic in 2000 to that in 2001?
Give a very brief answer. 1.04. What is the ratio of the Rent(as % of GDP) of Liberia in 2000 to that in 2001?
Your response must be concise. 0.98. What is the difference between the highest and the second highest Rent(as % of GDP) in Bahrain?
Give a very brief answer. 0. What is the difference between the highest and the second highest Rent(as % of GDP) in Central African Republic?
Your response must be concise. 0.36. What is the difference between the highest and the second highest Rent(as % of GDP) in Dominican Republic?
Offer a very short reply. 0.02. What is the difference between the highest and the second highest Rent(as % of GDP) in Liberia?
Offer a very short reply. 3.7. What is the difference between the highest and the lowest Rent(as % of GDP) of Bahrain?
Make the answer very short. 0. What is the difference between the highest and the lowest Rent(as % of GDP) of Central African Republic?
Your response must be concise. 3.91. What is the difference between the highest and the lowest Rent(as % of GDP) in Dominican Republic?
Ensure brevity in your answer.  0.07. What is the difference between the highest and the lowest Rent(as % of GDP) of Liberia?
Offer a terse response. 52.1. 